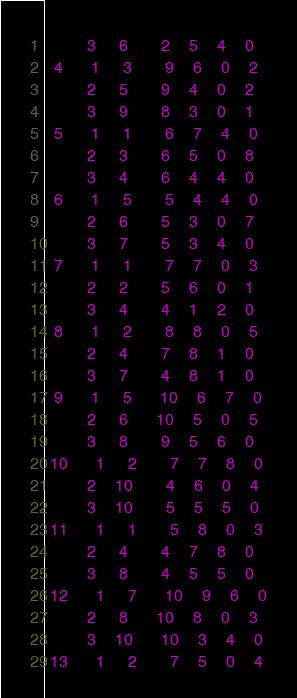<code> <loc_0><loc_0><loc_500><loc_500><_ObjectiveC_>         3     6       2    5    4    0
  4      1     3       9    6    0    2
         2     5       9    4    0    2
         3     9       8    3    0    1
  5      1     1       6    7    4    0
         2     3       6    5    0    8
         3     4       6    4    4    0
  6      1     5       5    4    4    0
         2     6       5    3    0    7
         3     7       5    3    4    0
  7      1     1       7    7    0    3
         2     2       5    6    0    1
         3     4       4    1    2    0
  8      1     2       8    8    0    5
         2     4       7    8    1    0
         3     7       4    8    1    0
  9      1     5      10    6    7    0
         2     6      10    5    0    5
         3     8       9    5    6    0
 10      1     2       7    7    8    0
         2    10       4    6    0    4
         3    10       5    5    5    0
 11      1     1       5    8    0    3
         2     4       4    7    8    0
         3     8       4    5    5    0
 12      1     7      10    9    6    0
         2     8      10    8    0    3
         3    10      10    3    4    0
 13      1     2       7    5    0    4</code> 